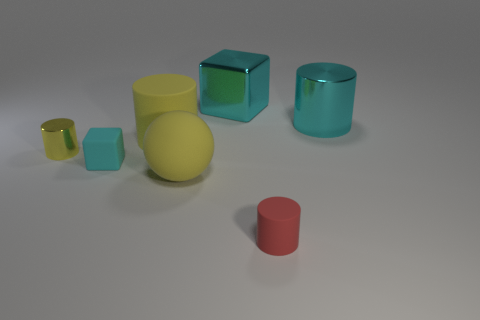Is the shape of the yellow shiny thing that is left of the tiny block the same as  the tiny cyan matte object?
Provide a succinct answer. No. What number of things are either large shiny objects or tiny objects that are left of the tiny red thing?
Your answer should be compact. 4. Is the material of the block that is behind the tiny yellow object the same as the small red cylinder?
Give a very brief answer. No. The cylinder that is left of the big cylinder that is left of the cyan cylinder is made of what material?
Your answer should be very brief. Metal. Are there more yellow cylinders on the right side of the large ball than small metal cylinders that are in front of the small metallic cylinder?
Ensure brevity in your answer.  No. The cyan metallic block is what size?
Your response must be concise. Large. Is the color of the metallic cylinder to the right of the metal block the same as the tiny cube?
Provide a succinct answer. Yes. There is a metallic object to the right of the tiny red rubber cylinder; is there a metallic cylinder in front of it?
Offer a very short reply. Yes. Is the number of yellow things to the right of the big shiny cylinder less than the number of yellow rubber things behind the tiny cyan block?
Keep it short and to the point. Yes. What is the size of the cyan object to the right of the cyan block right of the big yellow object that is behind the small yellow thing?
Keep it short and to the point. Large. 